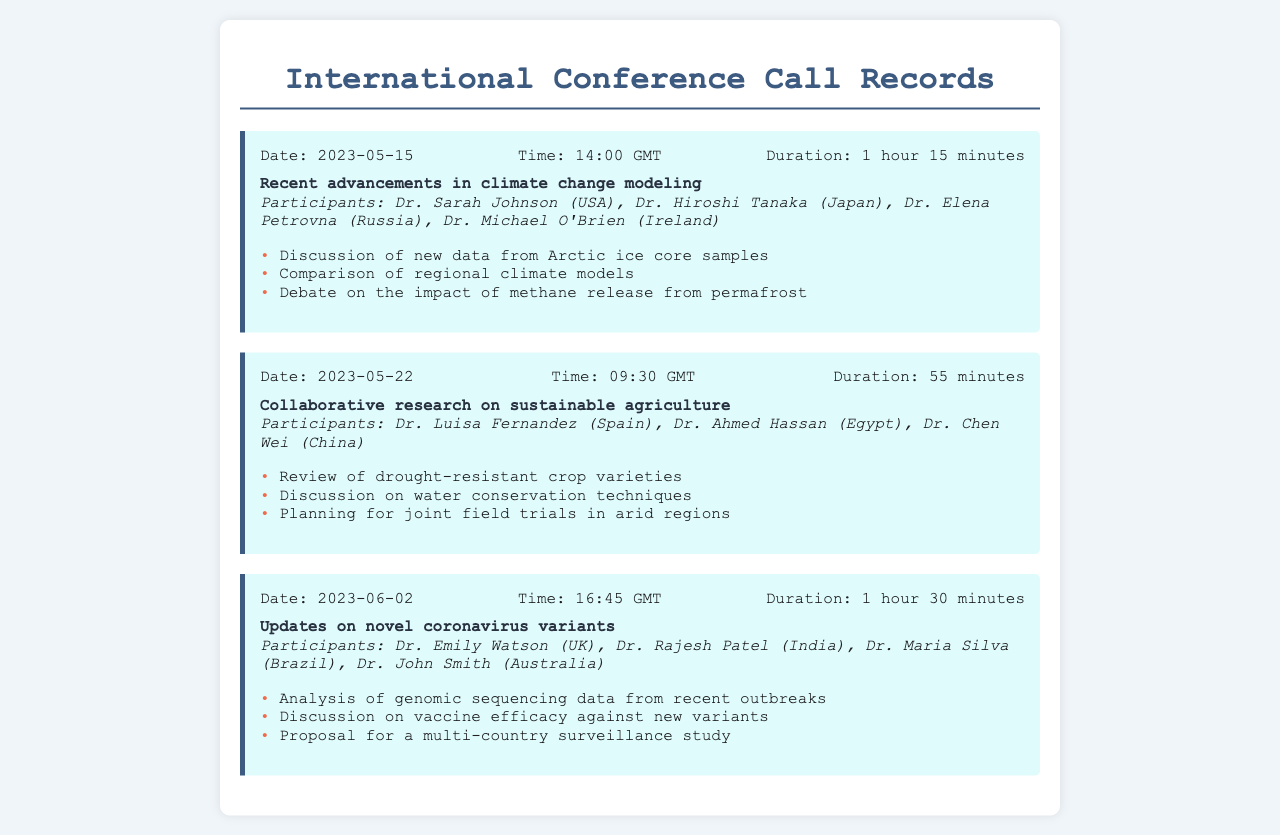What was the date of the first call? The first call took place on May 15, 2023, as indicated in the call header.
Answer: May 15, 2023 How long did the second call last? The duration of the second call is specified as 55 minutes in the call header.
Answer: 55 minutes Who participated in the call about sustainable agriculture? The participants for the call on sustainable agriculture are listed, including Dr. Luisa Fernandez, Dr. Ahmed Hassan, and Dr. Chen Wei.
Answer: Dr. Luisa Fernandez, Dr. Ahmed Hassan, Dr. Chen Wei What was a key point discussed in the climate change modeling call? The document lists key points, including discussion of new data from Arctic ice core samples as a notable point.
Answer: Discussion of new data from Arctic ice core samples How many participants were in the call regarding coronavirus variants? The number of participants is found in the call about novel coronavirus variants, which includes four individuals.
Answer: Four participants Which call lasted the longest? By comparing the durations listed, the longest call is identified as the one on novel coronavirus variants lasting 1 hour and 30 minutes.
Answer: 1 hour 30 minutes What topic was discussed on June 2, 2023? The specific topic for the call on this date is stated as updates on novel coronavirus variants.
Answer: Updates on novel coronavirus variants What are the names of the participants in the call from May 22? The participants of the May 22 call are indicated clearly in the document, including Dr. Luisa Fernandez, Dr. Ahmed Hassan, and Dr. Chen Wei.
Answer: Dr. Luisa Fernandez, Dr. Ahmed Hassan, Dr. Chen Wei 